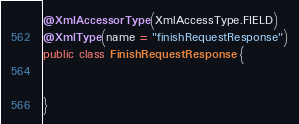Convert code to text. <code><loc_0><loc_0><loc_500><loc_500><_Java_>@XmlAccessorType(XmlAccessType.FIELD)
@XmlType(name = "finishRequestResponse")
public class FinishRequestResponse {


}
</code> 